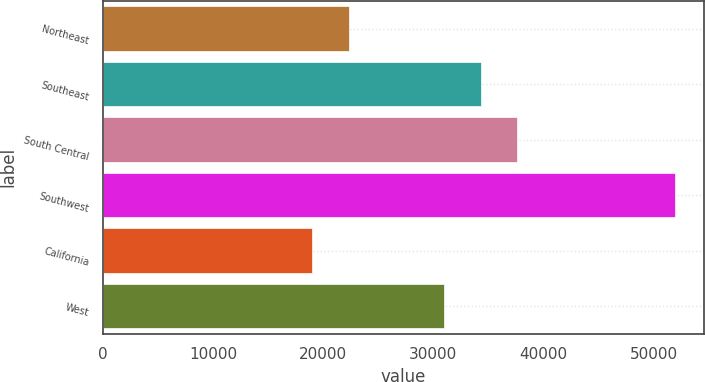<chart> <loc_0><loc_0><loc_500><loc_500><bar_chart><fcel>Northeast<fcel>Southeast<fcel>South Central<fcel>Southwest<fcel>California<fcel>West<nl><fcel>22300<fcel>34300<fcel>37600<fcel>52000<fcel>19000<fcel>31000<nl></chart> 